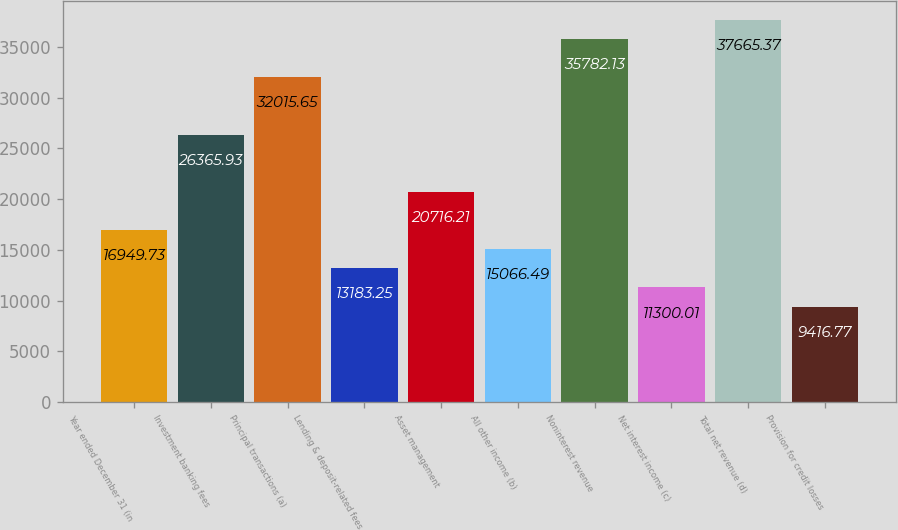<chart> <loc_0><loc_0><loc_500><loc_500><bar_chart><fcel>Year ended December 31 (in<fcel>Investment banking fees<fcel>Principal transactions (a)<fcel>Lending & deposit-related fees<fcel>Asset management<fcel>All other income (b)<fcel>Noninterest revenue<fcel>Net interest income (c)<fcel>Total net revenue (d)<fcel>Provision for credit losses<nl><fcel>16949.7<fcel>26365.9<fcel>32015.7<fcel>13183.2<fcel>20716.2<fcel>15066.5<fcel>35782.1<fcel>11300<fcel>37665.4<fcel>9416.77<nl></chart> 